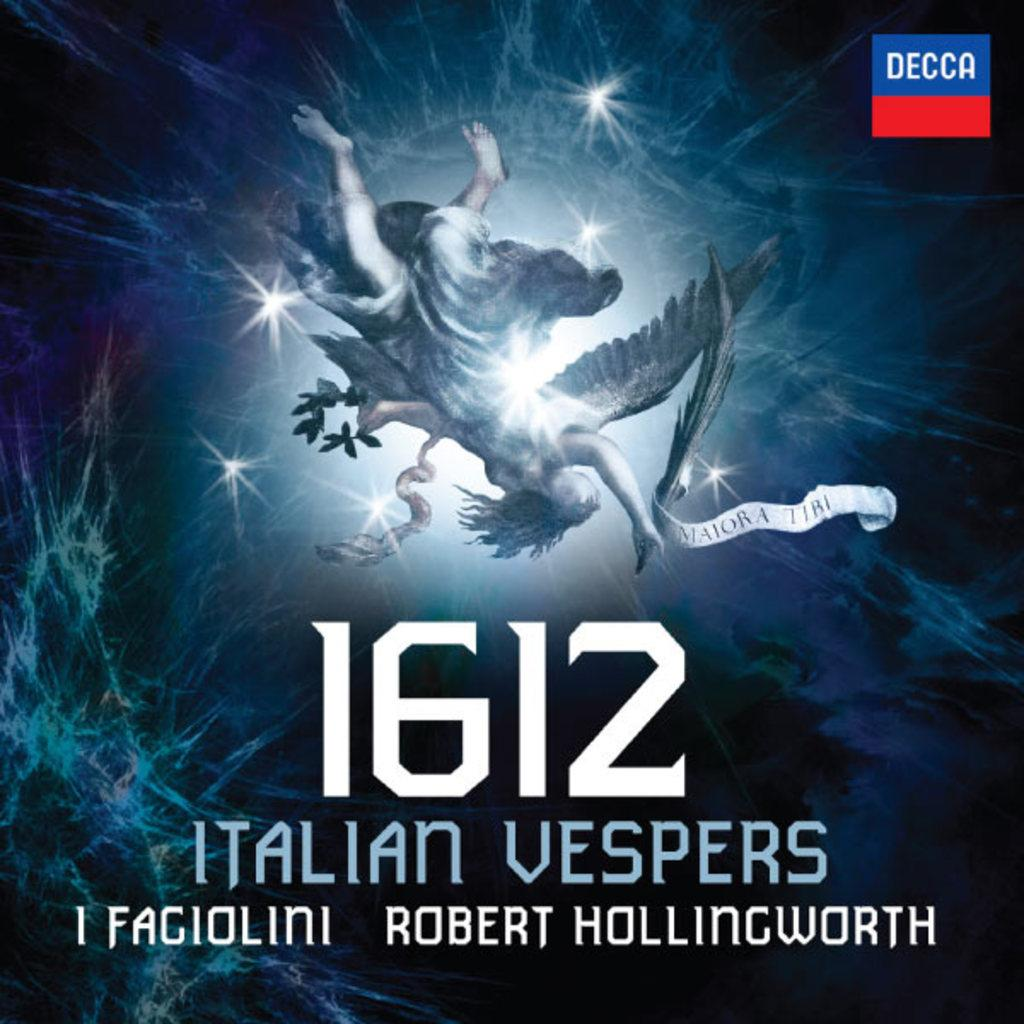<image>
Provide a brief description of the given image. A Decca Records label for 1612 Italian Vespers is shown. 